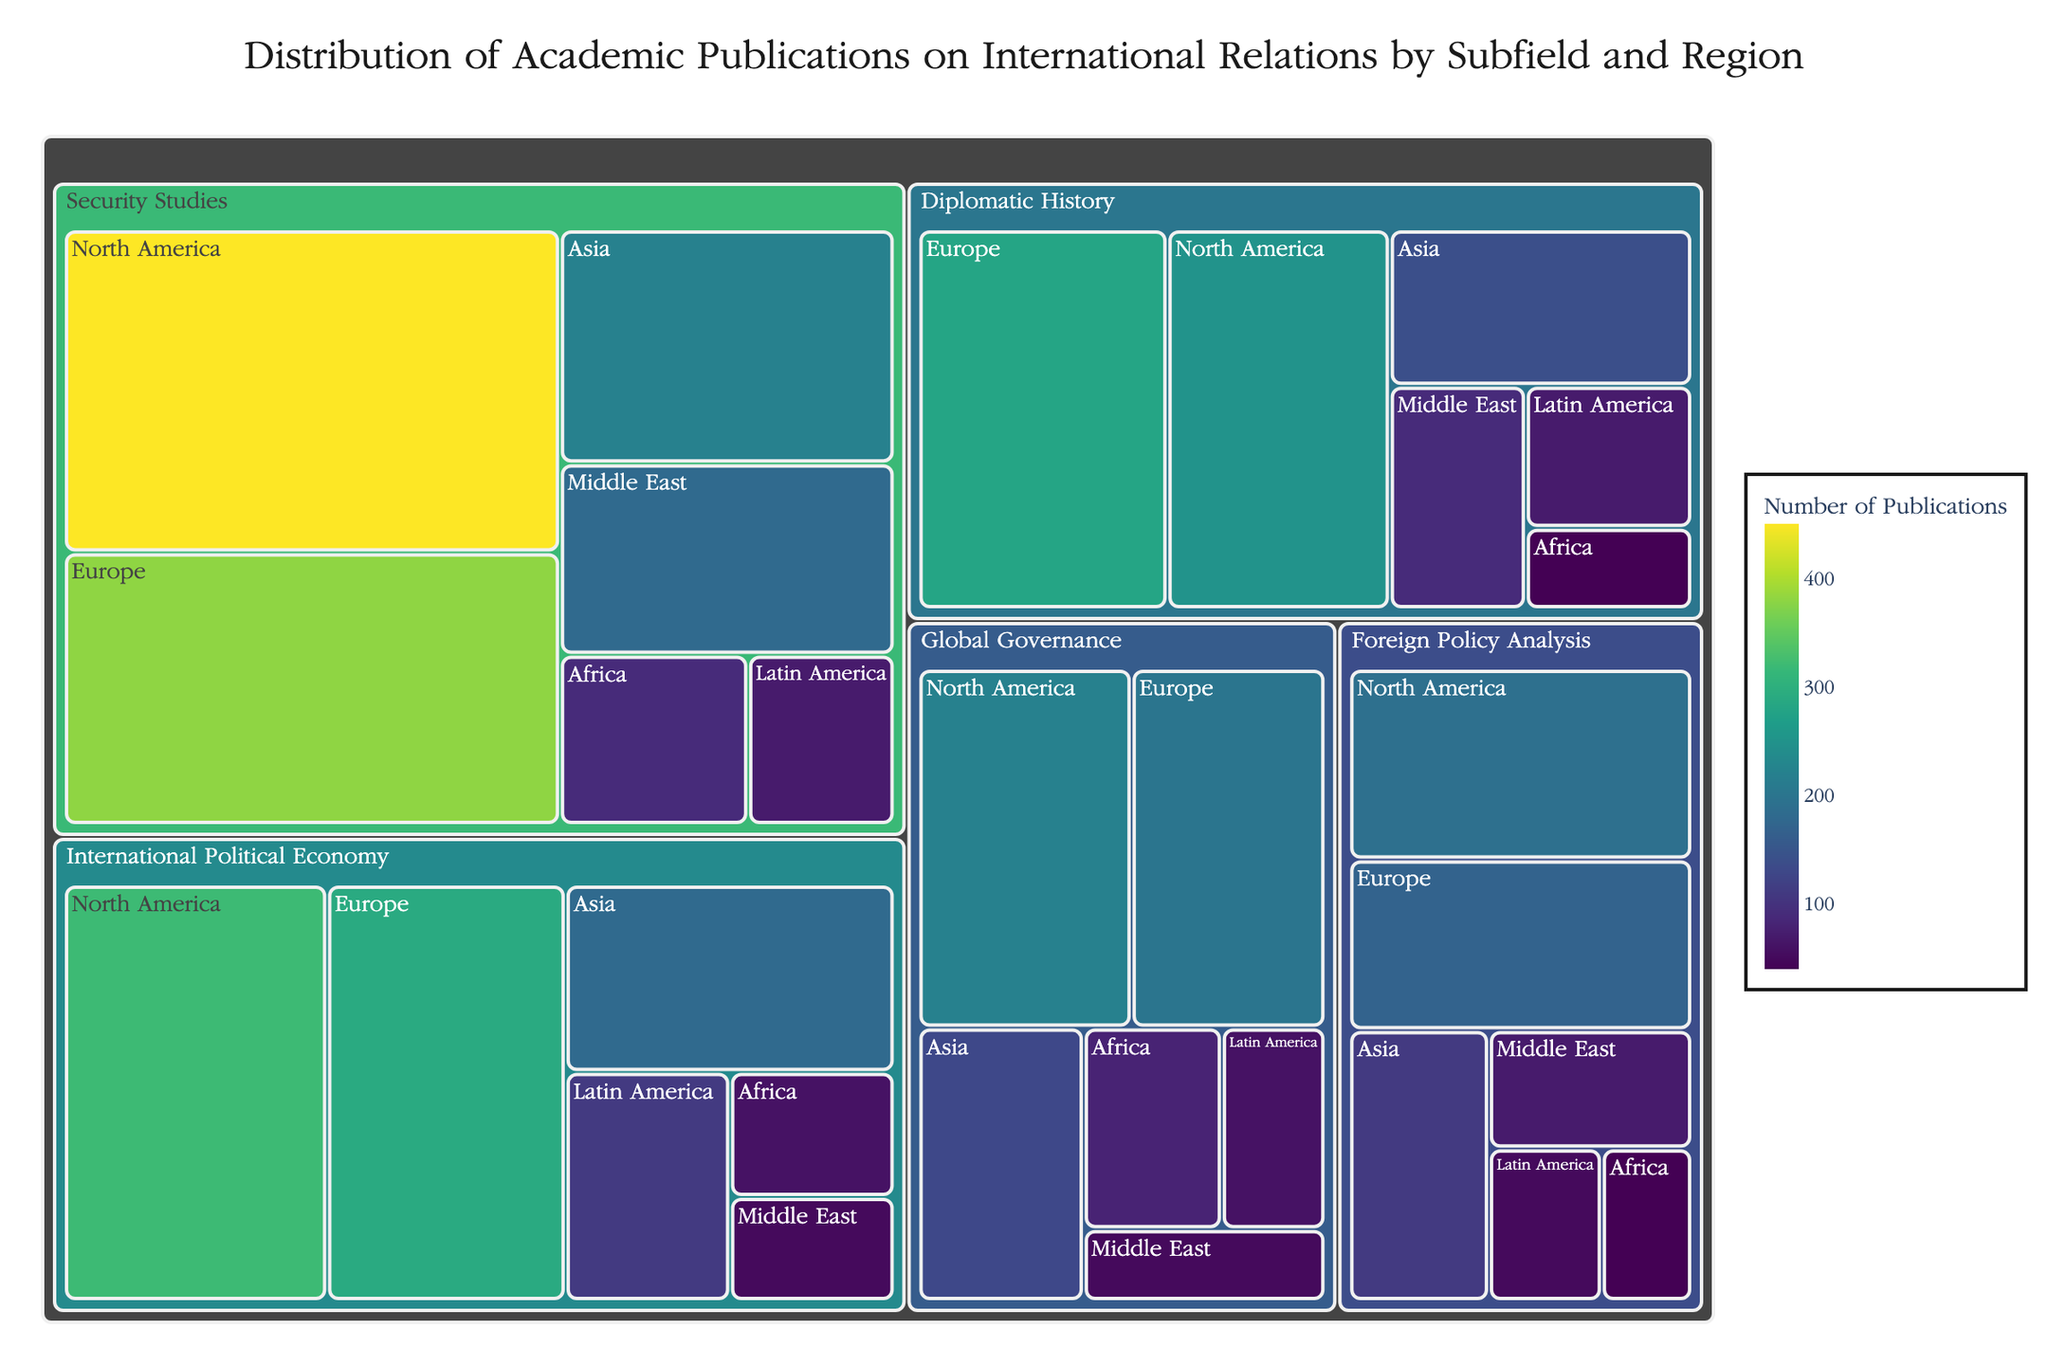What's the title of the treemap? The title of the treemap is located at the top of the figure. It provides a brief description of what the treemap represents. The title is 'Distribution of Academic Publications on International Relations by Subfield and Region'.
Answer: Distribution of Academic Publications on International Relations by Subfield and Region Which subfield has the most publications in North America? Look for the largest block within the 'North America' region part of the treemap and identify which subfield it belongs to. The largest block in North America corresponds to 'Security Studies'.
Answer: Security Studies How many more publications are there in European Security Studies compared to African Security Studies? Find the blocks representing 'Security Studies' in Europe and Africa and compare their sizes. Europe has 380 publications, and Africa has 90 publications. The difference is 380 - 90 = 290.
Answer: 290 Which region has the least publications in the 'Global Governance' subfield? Compare the sizes of the blocks corresponding to various regions within the 'Global Governance' subfield. The region with the smallest block is 'Middle East' with 50 publications.
Answer: Middle East What is the total number of publications in the 'International Political Economy' subfield? Sum the number of publications in all regions for 'International Political Economy'. The regions are North America (320), Europe (290), Asia (180), Latin America (110), Africa (60), and Middle East (50). The total is 320 + 290 + 180 + 110 + 60 + 50 = 1010.
Answer: 1010 Compare the number of publications between 'Diplomatic History' in Asia and 'Foreign Policy Analysis' in Europe. Which one is higher? Look at the sizes of the blocks for 'Diplomatic History' in Asia (140) and 'Foreign Policy Analysis' in Europe (170). The number of publications for 'Foreign Policy Analysis' in Europe is larger.
Answer: Foreign Policy Analysis in Europe How many subfields have publications in Africa? Identify the number of unique subfield blocks within the 'Africa' region. There are blocks for five subfields: 'Security Studies', 'International Political Economy', 'Diplomatic History', 'Global Governance', and 'Foreign Policy Analysis'.
Answer: Five What color represents the highest number of publications within the treemap? The treemap uses a Viridis color scale where darker colors correspond to higher values. The darkest color will represent the highest number of publications. The block with the highest number of publications (Security Studies in North America, 450) has the darkest color.
Answer: Dark Green What is the difference in the number of publications between 'Security Studies' and 'Global Governance' in North America? Find the blocks for 'Security Studies' (450) and 'Global Governance' (220) in North America. The difference is 450 - 220 = 230.
Answer: 230 Which subfield region pairs have exactly 60 publications? Look through the treemap blocks and identify pairs with exactly 60 publications. There are two pairs: 'International Political Economy' in Africa and 'Global Governance' in Latin America.
Answer: International Political Economy in Africa and Global Governance in Latin America 